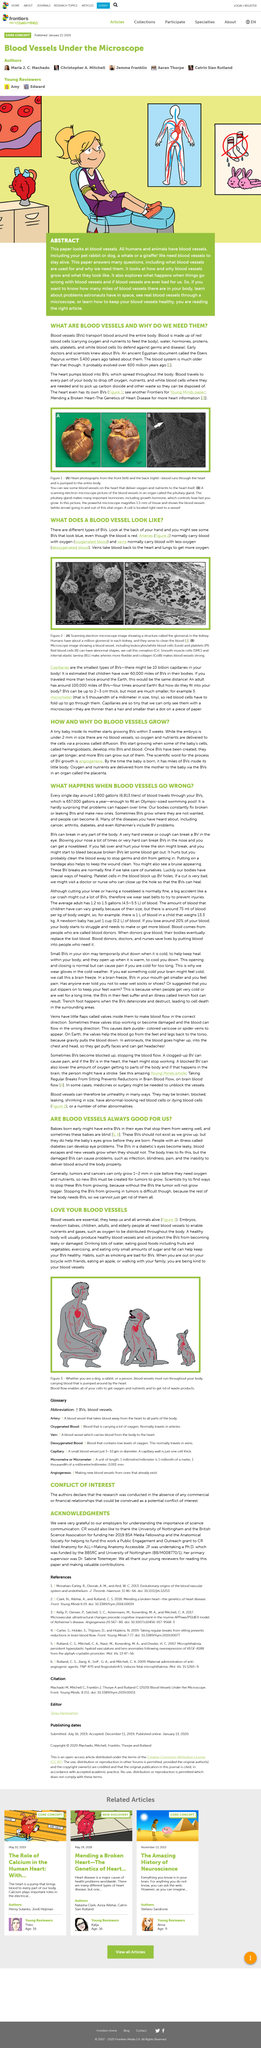Mention a couple of crucial points in this snapshot. Smoking is detrimental to the health of blood vessels. Yes, it has been determined that babies born with extra bodyvideos (BVs) can affect their sight. The depicted organ in the right-hand side image is blood vessels originating from the heart. Angiogenesis is the scientific term for the process of blood vessel growth. Blood vessels transport blood throughout the body. 